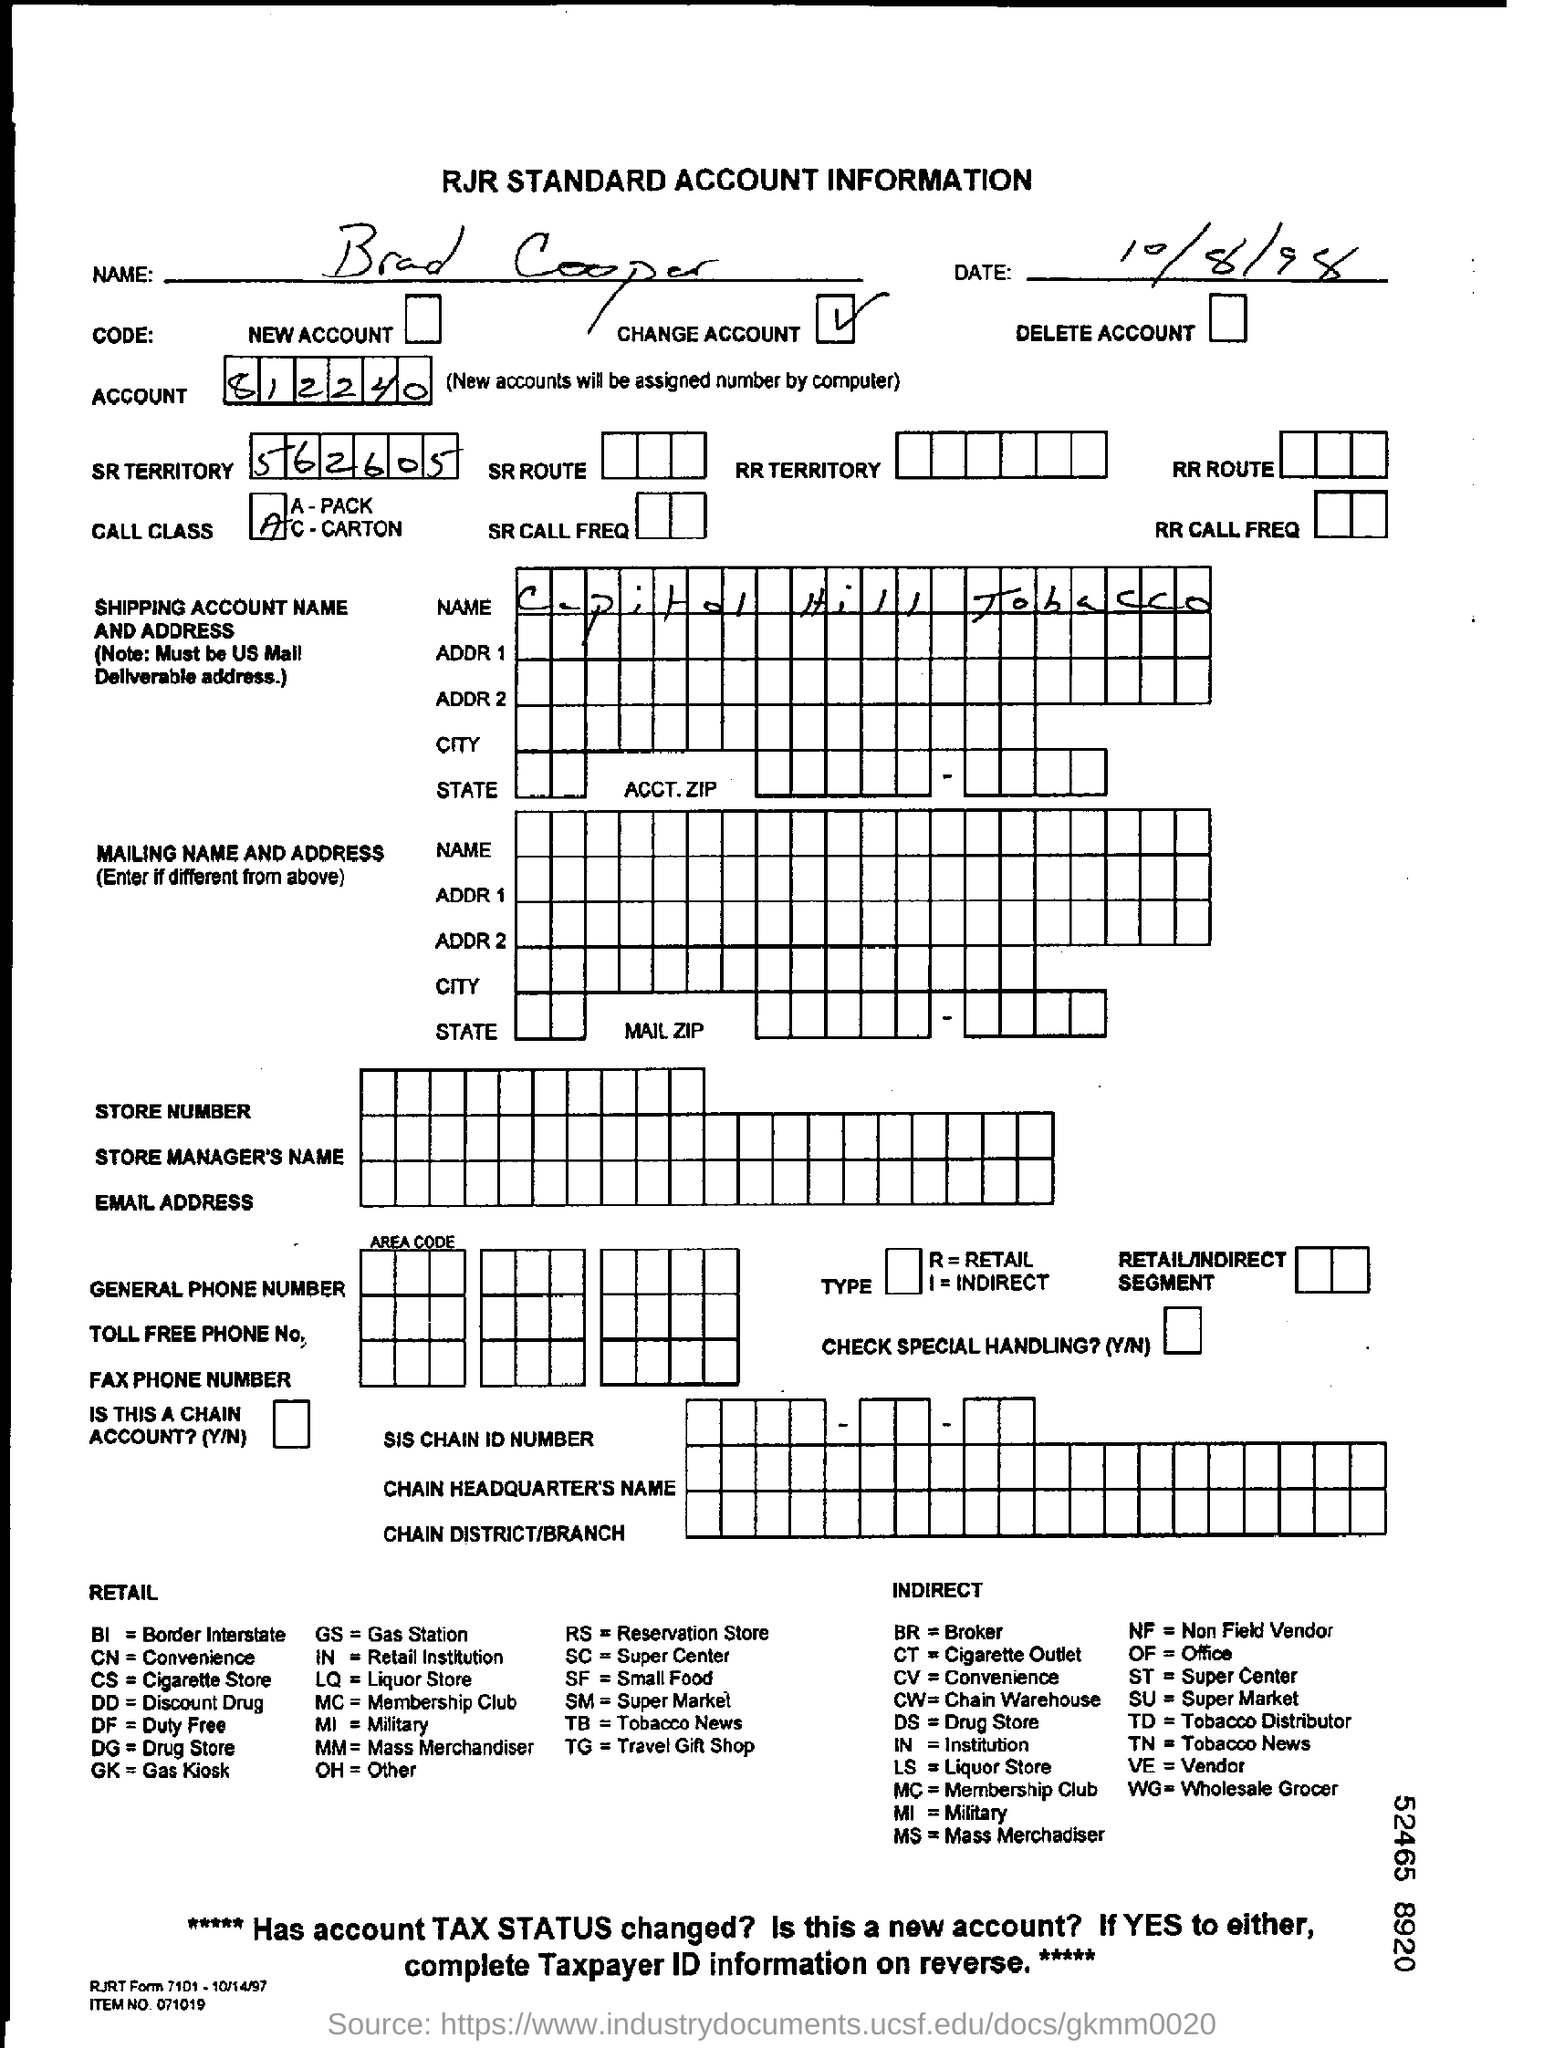What is the name of the person in account information?
Ensure brevity in your answer.  Brad Cooper. What is the date in the account information?
Ensure brevity in your answer.  10/8/98. What is the account number of the brad cooper?
Your answer should be compact. 812240. What is the sr territory?
Offer a very short reply. 562605. What is the name of shipping account name?
Ensure brevity in your answer.  Capital hill tobacco. 